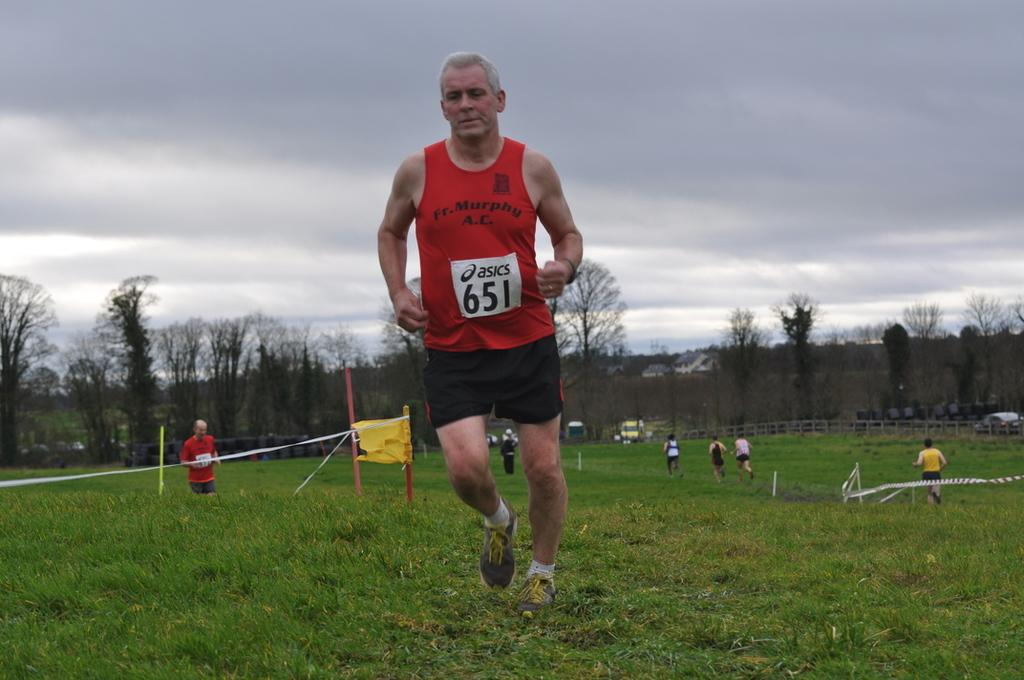What is the man in the foreground of the image doing? The man in the foreground of the image is running. On what surface is the man running? The man is running on the grass. What can be seen in the background of the image? In the background of the image, there are safety poles, persons running, trees, houses, and a cloud. What type of sack is the man carrying while running in the image? There is no sack visible in the image; the man is not carrying anything while running. 